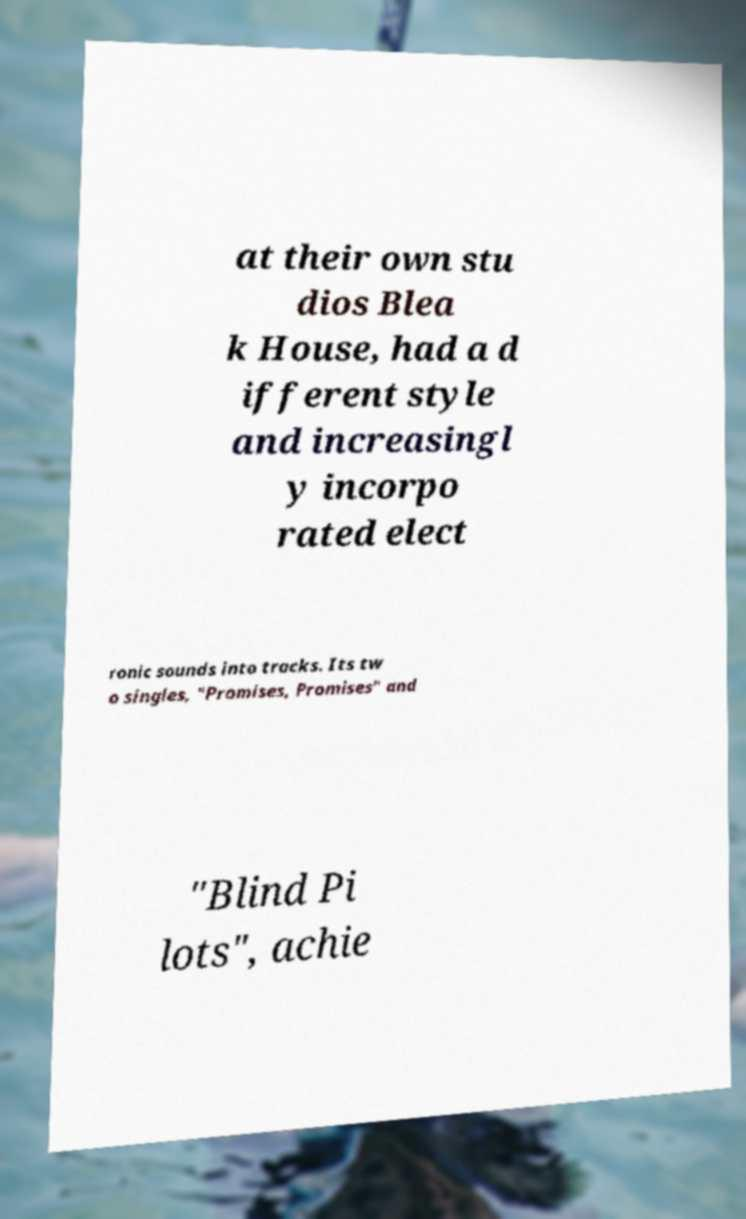There's text embedded in this image that I need extracted. Can you transcribe it verbatim? at their own stu dios Blea k House, had a d ifferent style and increasingl y incorpo rated elect ronic sounds into tracks. Its tw o singles, "Promises, Promises" and "Blind Pi lots", achie 